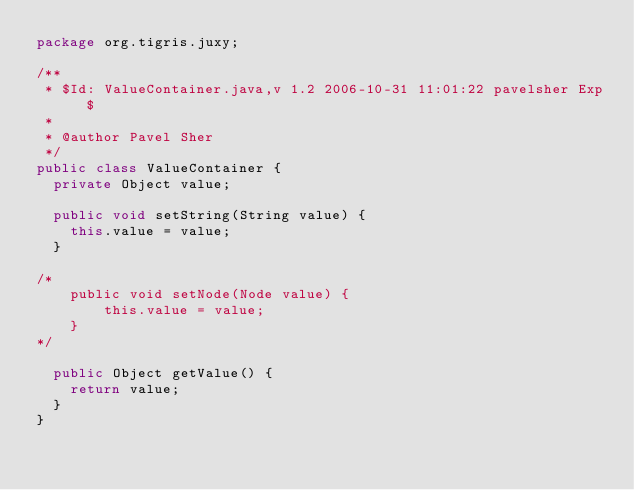<code> <loc_0><loc_0><loc_500><loc_500><_Java_>package org.tigris.juxy;

/**
 * $Id: ValueContainer.java,v 1.2 2006-10-31 11:01:22 pavelsher Exp $
 *
 * @author Pavel Sher
 */
public class ValueContainer {
  private Object value;

  public void setString(String value) {
    this.value = value;
  }

/*
    public void setNode(Node value) {
        this.value = value;
    }
*/

  public Object getValue() {
    return value;
  }
}
</code> 